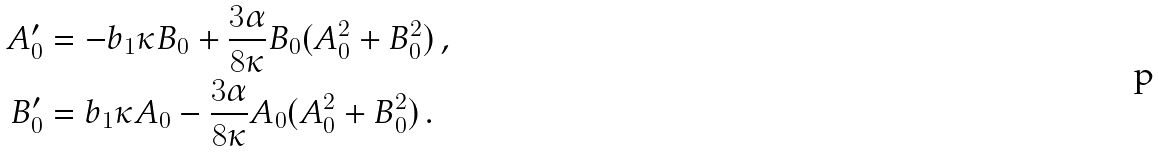Convert formula to latex. <formula><loc_0><loc_0><loc_500><loc_500>A _ { 0 } ^ { \prime } & = - b _ { 1 } \kappa B _ { 0 } + \frac { 3 \alpha } { 8 \kappa } B _ { 0 } ( A _ { 0 } ^ { 2 } + B _ { 0 } ^ { 2 } ) \, , \\ B _ { 0 } ^ { \prime } & = b _ { 1 } \kappa A _ { 0 } - \frac { 3 \alpha } { 8 \kappa } A _ { 0 } ( A _ { 0 } ^ { 2 } + B _ { 0 } ^ { 2 } ) \, .</formula> 